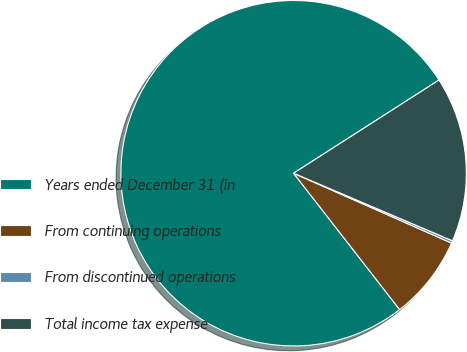Convert chart. <chart><loc_0><loc_0><loc_500><loc_500><pie_chart><fcel>Years ended December 31 (in<fcel>From continuing operations<fcel>From discontinued operations<fcel>Total income tax expense<nl><fcel>76.45%<fcel>7.85%<fcel>0.23%<fcel>15.47%<nl></chart> 